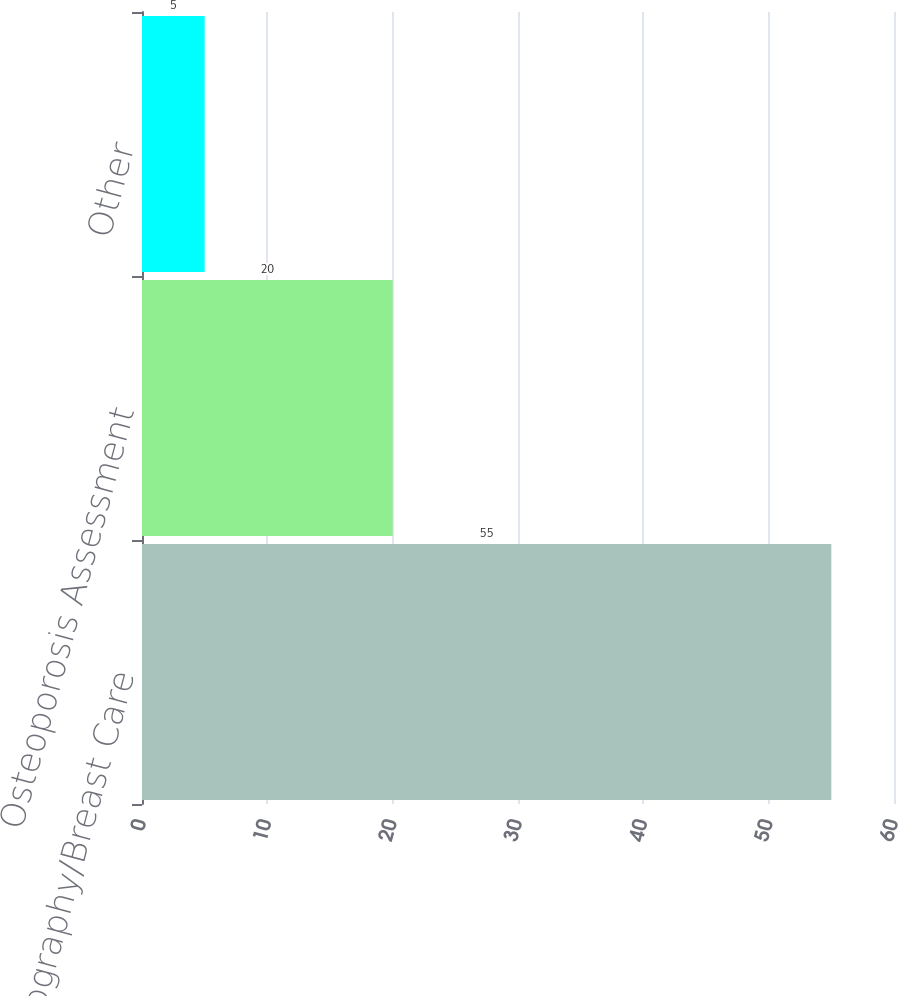Convert chart to OTSL. <chart><loc_0><loc_0><loc_500><loc_500><bar_chart><fcel>Mammography/Breast Care<fcel>Osteoporosis Assessment<fcel>Other<nl><fcel>55<fcel>20<fcel>5<nl></chart> 